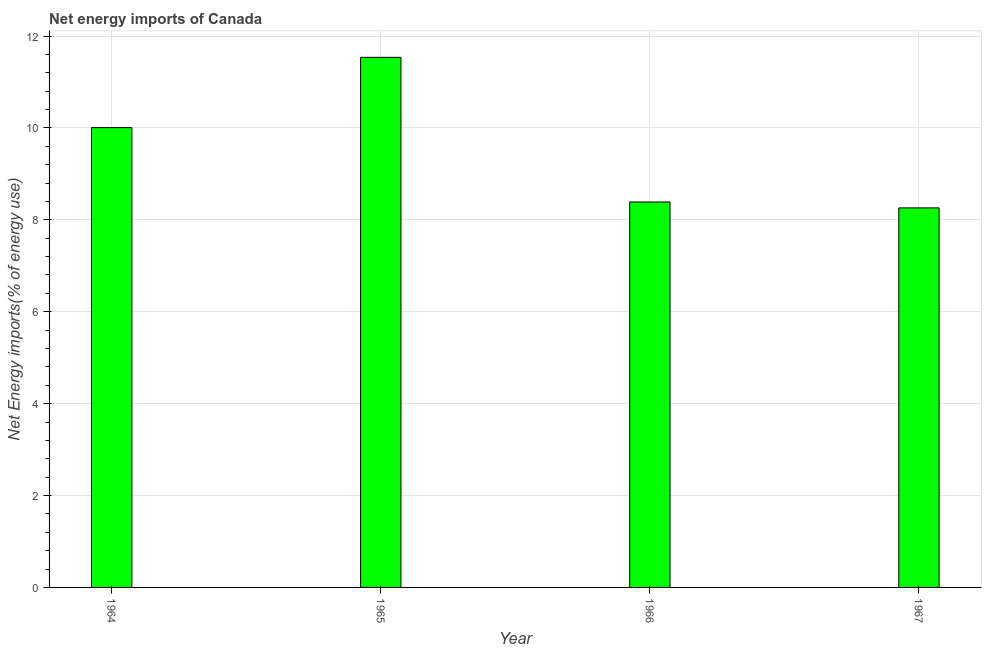Does the graph contain grids?
Give a very brief answer. Yes. What is the title of the graph?
Your answer should be very brief. Net energy imports of Canada. What is the label or title of the X-axis?
Offer a very short reply. Year. What is the label or title of the Y-axis?
Your answer should be compact. Net Energy imports(% of energy use). What is the energy imports in 1967?
Provide a short and direct response. 8.26. Across all years, what is the maximum energy imports?
Give a very brief answer. 11.54. Across all years, what is the minimum energy imports?
Ensure brevity in your answer.  8.26. In which year was the energy imports maximum?
Ensure brevity in your answer.  1965. In which year was the energy imports minimum?
Your answer should be compact. 1967. What is the sum of the energy imports?
Give a very brief answer. 38.19. What is the difference between the energy imports in 1965 and 1967?
Give a very brief answer. 3.28. What is the average energy imports per year?
Ensure brevity in your answer.  9.55. What is the median energy imports?
Make the answer very short. 9.2. In how many years, is the energy imports greater than 1.6 %?
Make the answer very short. 4. What is the ratio of the energy imports in 1966 to that in 1967?
Keep it short and to the point. 1.02. Is the energy imports in 1964 less than that in 1965?
Offer a terse response. Yes. What is the difference between the highest and the second highest energy imports?
Your answer should be compact. 1.53. Is the sum of the energy imports in 1965 and 1966 greater than the maximum energy imports across all years?
Make the answer very short. Yes. What is the difference between the highest and the lowest energy imports?
Provide a short and direct response. 3.28. How many bars are there?
Your answer should be very brief. 4. What is the difference between two consecutive major ticks on the Y-axis?
Your response must be concise. 2. What is the Net Energy imports(% of energy use) of 1964?
Give a very brief answer. 10.01. What is the Net Energy imports(% of energy use) of 1965?
Provide a short and direct response. 11.54. What is the Net Energy imports(% of energy use) in 1966?
Your answer should be compact. 8.39. What is the Net Energy imports(% of energy use) of 1967?
Ensure brevity in your answer.  8.26. What is the difference between the Net Energy imports(% of energy use) in 1964 and 1965?
Offer a terse response. -1.53. What is the difference between the Net Energy imports(% of energy use) in 1964 and 1966?
Your answer should be compact. 1.62. What is the difference between the Net Energy imports(% of energy use) in 1964 and 1967?
Give a very brief answer. 1.75. What is the difference between the Net Energy imports(% of energy use) in 1965 and 1966?
Your answer should be compact. 3.15. What is the difference between the Net Energy imports(% of energy use) in 1965 and 1967?
Give a very brief answer. 3.28. What is the difference between the Net Energy imports(% of energy use) in 1966 and 1967?
Offer a terse response. 0.13. What is the ratio of the Net Energy imports(% of energy use) in 1964 to that in 1965?
Your response must be concise. 0.87. What is the ratio of the Net Energy imports(% of energy use) in 1964 to that in 1966?
Your response must be concise. 1.19. What is the ratio of the Net Energy imports(% of energy use) in 1964 to that in 1967?
Make the answer very short. 1.21. What is the ratio of the Net Energy imports(% of energy use) in 1965 to that in 1966?
Keep it short and to the point. 1.38. What is the ratio of the Net Energy imports(% of energy use) in 1965 to that in 1967?
Offer a terse response. 1.4. What is the ratio of the Net Energy imports(% of energy use) in 1966 to that in 1967?
Ensure brevity in your answer.  1.02. 